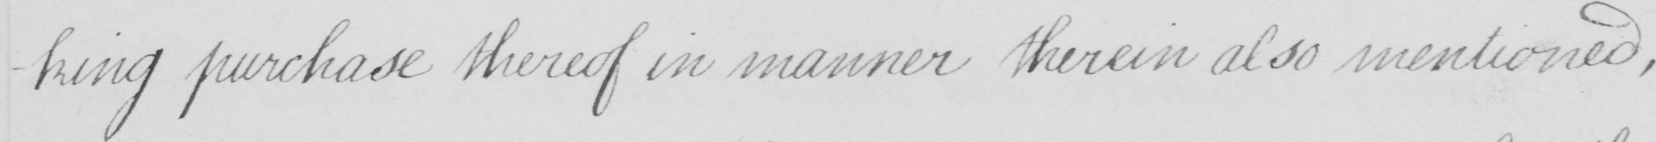Can you read and transcribe this handwriting? -king purchase thereof in manner therein also mentioned , 